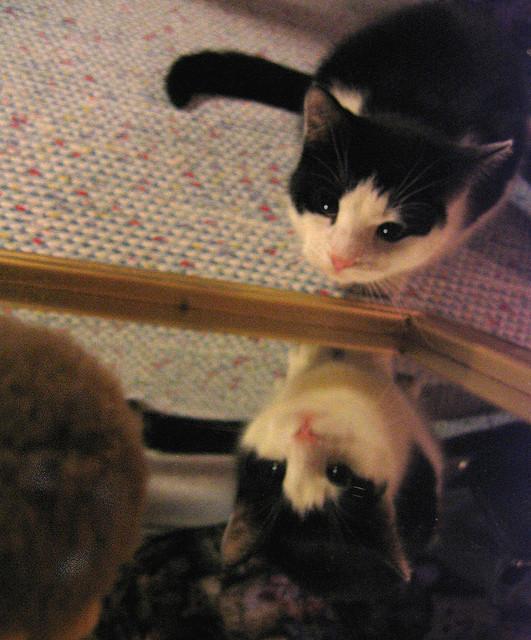How many cats are in this picture?
Give a very brief answer. 1. How many cats can be seen?
Give a very brief answer. 2. How many trains can you see?
Give a very brief answer. 0. 